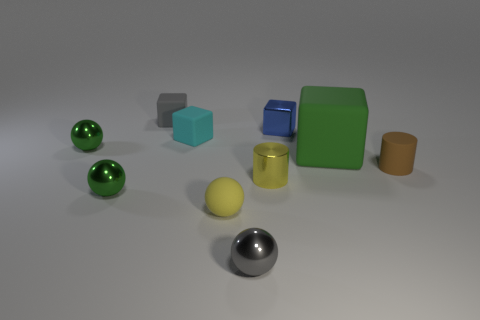There is a small sphere that is the same color as the small metallic cylinder; what material is it?
Ensure brevity in your answer.  Rubber. Is the color of the metal cylinder the same as the matte sphere?
Your answer should be very brief. Yes. What number of tiny green things are the same material as the blue block?
Your response must be concise. 2. How many things are cubes to the left of the blue block or matte cubes that are to the left of the cyan cube?
Keep it short and to the point. 2. Is the number of yellow objects that are right of the small blue thing greater than the number of tiny green metal things right of the small brown thing?
Offer a very short reply. No. The tiny cube to the right of the rubber ball is what color?
Your answer should be compact. Blue. Is there a tiny green metal object of the same shape as the small yellow rubber thing?
Your answer should be very brief. Yes. How many cyan things are either small blocks or tiny things?
Ensure brevity in your answer.  1. Is there a purple sphere that has the same size as the brown cylinder?
Ensure brevity in your answer.  No. What number of cylinders are there?
Offer a terse response. 2. 